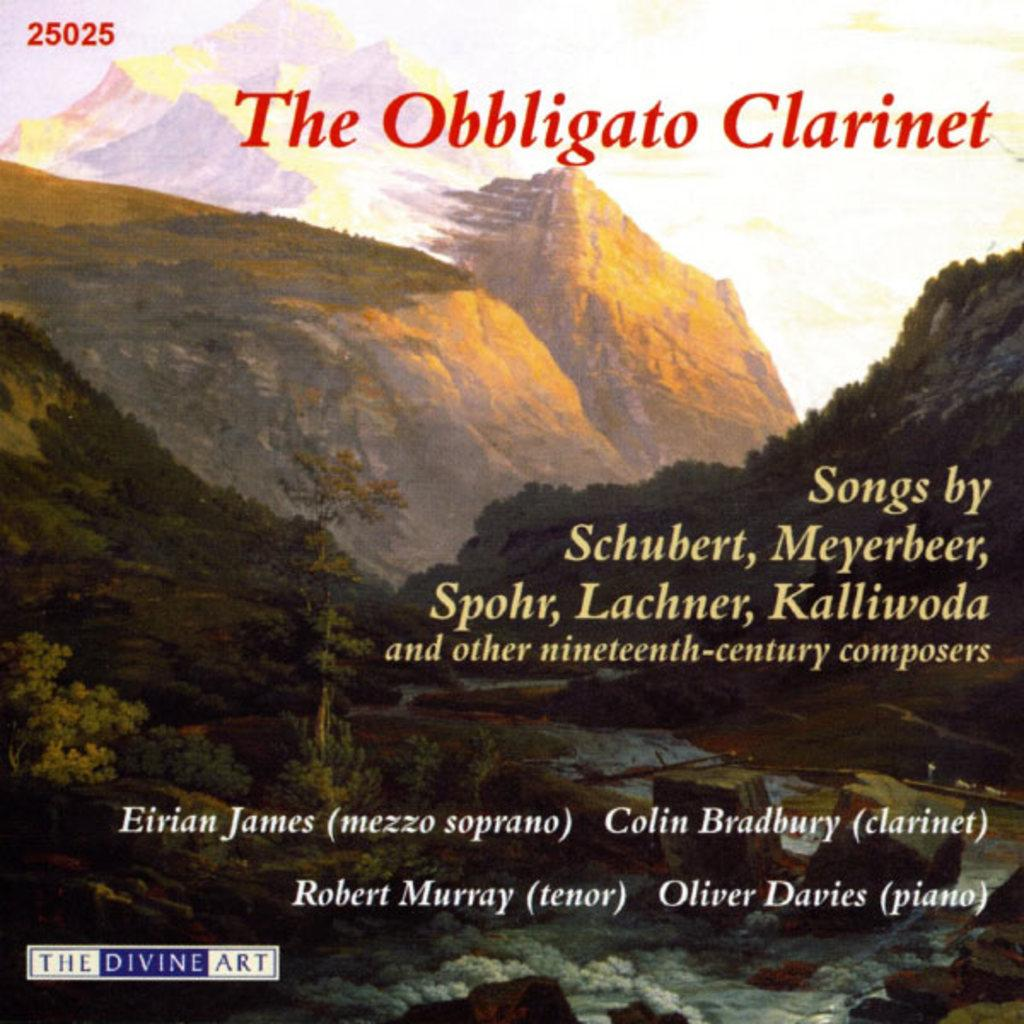Provide a one-sentence caption for the provided image. The cover art for The obbligato Clarinet, a collection of 19th century composers. 